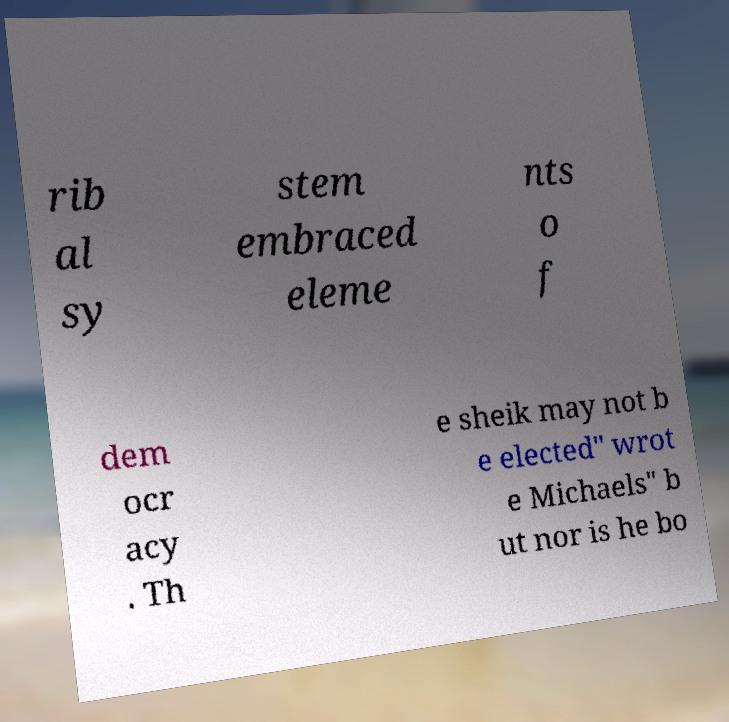Please identify and transcribe the text found in this image. rib al sy stem embraced eleme nts o f dem ocr acy . Th e sheik may not b e elected" wrot e Michaels" b ut nor is he bo 